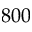Convert formula to latex. <formula><loc_0><loc_0><loc_500><loc_500>8 0 0</formula> 